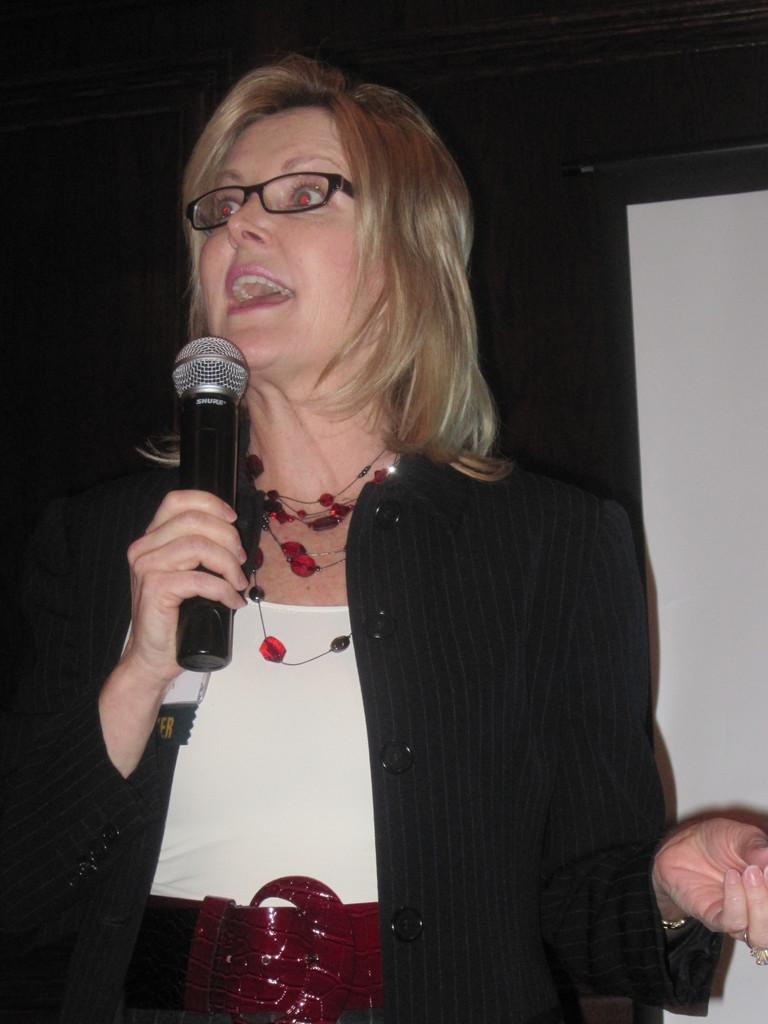What is the main subject of the image? The main subject of the image is a woman. What is the woman holding in her hand? The woman is holding a mic in her hand. Can you describe the woman's appearance? The woman is wearing spectacles and a black color coat. What can be seen on the right side of the image? There is a projector screen on the right side of the image. How does the woman cough while holding the mic in the image? There is no indication in the image that the woman is coughing; she is holding a mic and appears to be focused on her task. 